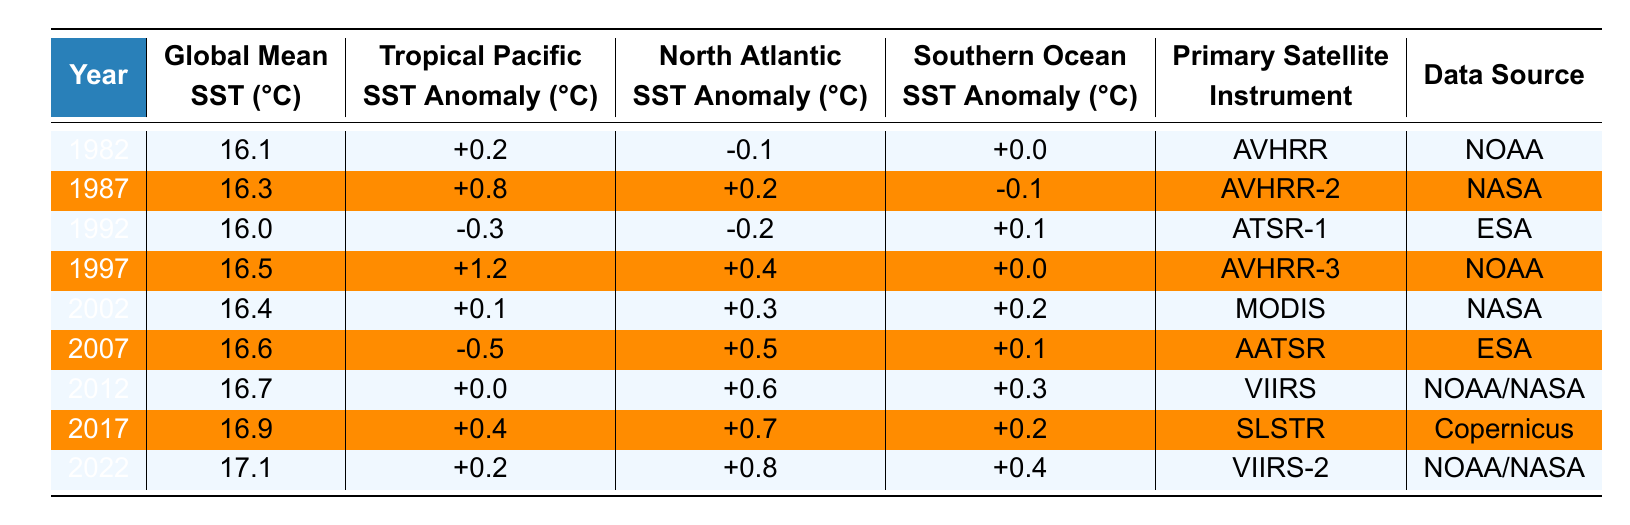What was the Global Mean SST in 1997? The table shows that the Global Mean SST for the year 1997 is 16.5°C.
Answer: 16.5°C What is the SST anomaly for the North Atlantic in 2022? According to the table, the North Atlantic SST Anomaly for the year 2022 is +0.8°C.
Answer: +0.8°C In which year did the Tropical Pacific SST Anomaly reach its highest value and what was that value? The highest Tropical Pacific SST Anomaly in the table is +1.2°C, which occurred in the year 1997.
Answer: 1997, +1.2°C What is the average Global Mean SST from the years 1982 to 2022? Calculating the average, the Global Mean SST values are: 16.1, 16.3, 16.0, 16.5, 16.4, 16.6, 16.7, 16.9, 17.1. The sum is 148.6, and there are 9 years, so the average is 148.6/9 = 16.51°C.
Answer: 16.51°C Did the Southern Ocean SST Anomaly ever drop below 0 from 1982 to 2022? Yes, the table indicates that the Southern Ocean SST Anomaly was +0.0°C in 1982 and does not go below 0 until 2007 when it is +0.1°C, meaning it never drops below 0 during this period.
Answer: No What trend can be observed in the Global Mean SST from 1982 to 2022? By examining the values from the table, the Global Mean SST steadily increases from 16.1°C in 1982 to 17.1°C in 2022, indicating a warming trend over the 40-year period.
Answer: Increasing trend Which satellite instrument had the highest SST anomaly readings in the table? The AVHRR-3 instrument in 1997 had the highest SST anomaly for the Tropical Pacific at +1.2°C.
Answer: AVHRR-3 What was the difference in Global Mean SST between 1982 and 2022? The Global Mean SST was 16.1°C in 1982 and 17.1°C in 2022, so the difference is 17.1 - 16.1 = 1.0°C.
Answer: 1.0°C How many different satellite instruments were used to gather data from 1982 to 2022? The table lists 5 different satellite instruments: AVHRR, AVHRR-2, ATSR-1, AVHRR-3, MODIS, AATSR, VIIRS, SLSTR, and VIIRS-2, for a total of 9 instruments used.
Answer: 9 instruments In which year did the Southern Ocean SST Anomaly have a value of +0.3°C? According to the table, the Southern Ocean SST Anomaly was +0.3°C in the year 2012.
Answer: 2012 